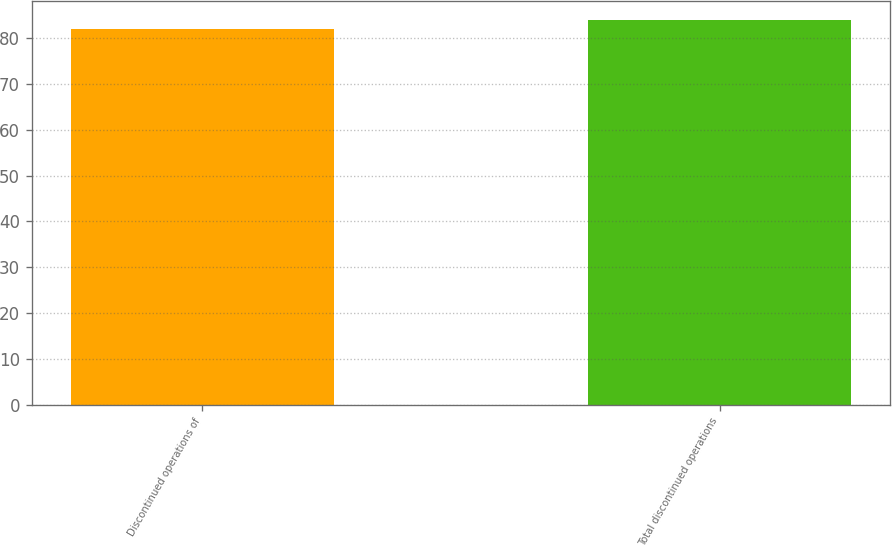<chart> <loc_0><loc_0><loc_500><loc_500><bar_chart><fcel>Discontinued operations of<fcel>Total discontinued operations<nl><fcel>82<fcel>84<nl></chart> 